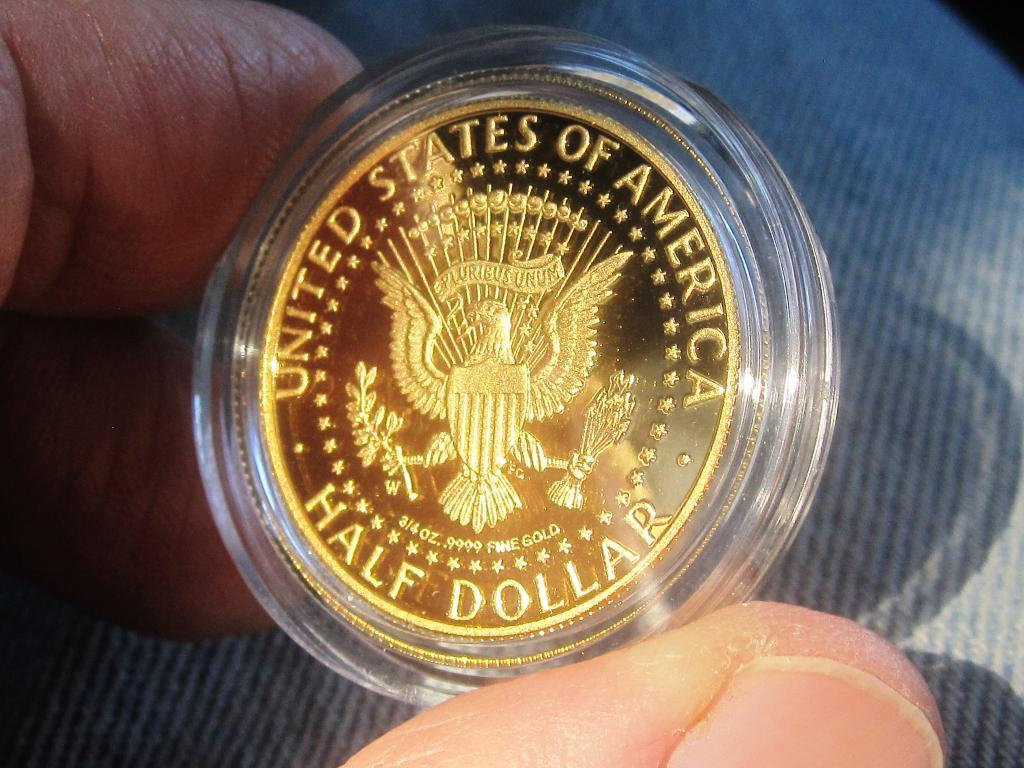<image>
Give a short and clear explanation of the subsequent image. A person holding a US half dollar in a case in their fingers. 